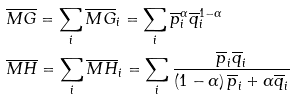Convert formula to latex. <formula><loc_0><loc_0><loc_500><loc_500>& \overline { M G } = \sum _ { i } \overline { M G } _ { i } = \sum _ { i } \overline { p } ^ { \alpha } _ { i } \overline { q } ^ { 1 - \alpha } _ { i } \\ & \overline { M H } = \sum _ { i } \overline { M H } _ { i } = \sum _ { i } \frac { \overline { p } _ { i } \overline { q } _ { i } } { \left ( 1 - \alpha \right ) \overline { p } _ { i } + \alpha \overline { q } _ { i } }</formula> 